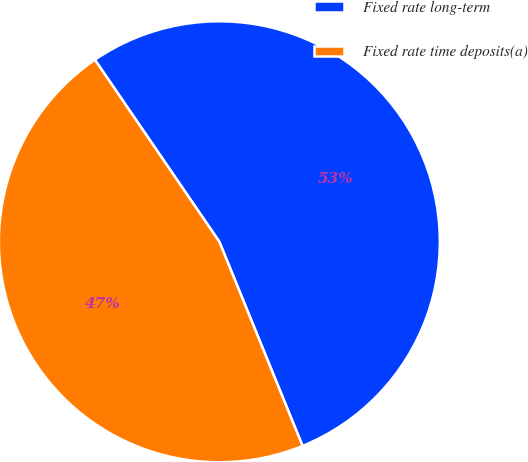Convert chart to OTSL. <chart><loc_0><loc_0><loc_500><loc_500><pie_chart><fcel>Fixed rate long-term<fcel>Fixed rate time deposits(a)<nl><fcel>53.39%<fcel>46.61%<nl></chart> 